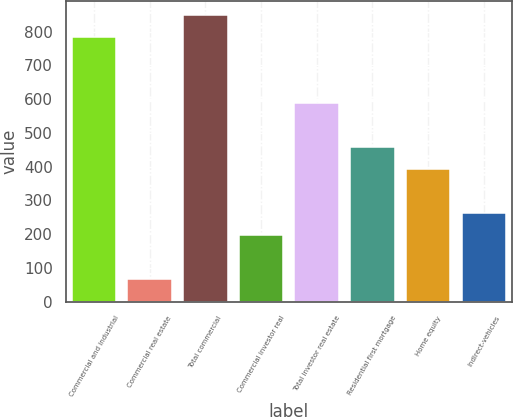<chart> <loc_0><loc_0><loc_500><loc_500><bar_chart><fcel>Commercial and industrial<fcel>Commercial real estate<fcel>Total commercial<fcel>Commercial investor real<fcel>Total investor real estate<fcel>Residential first mortgage<fcel>Home equity<fcel>Indirect-vehicles<nl><fcel>784.2<fcel>68.1<fcel>849.3<fcel>198.3<fcel>588.9<fcel>458.7<fcel>393.6<fcel>263.4<nl></chart> 